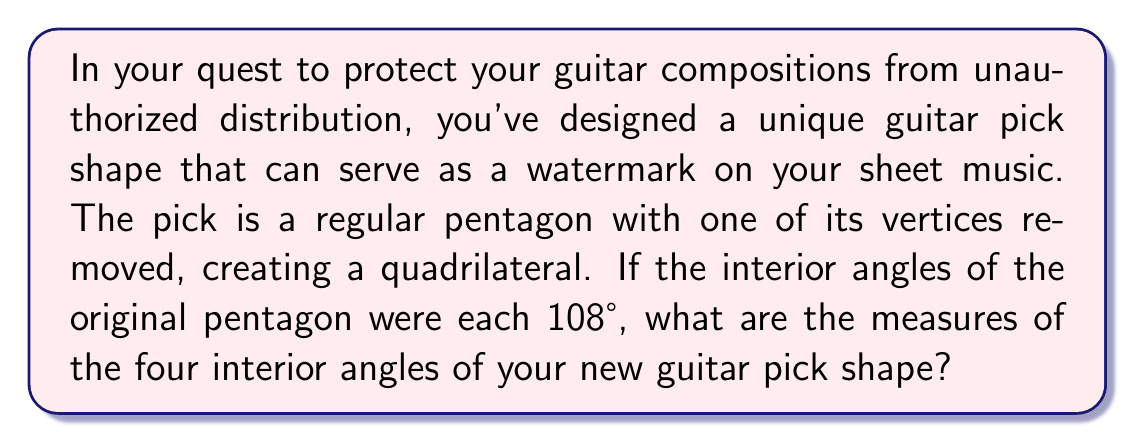Teach me how to tackle this problem. Let's approach this step-by-step:

1) First, recall that the sum of interior angles of a pentagon is given by the formula:
   $$(n-2) \times 180°$$
   where $n$ is the number of sides. For a pentagon, $n=5$:
   $$(5-2) \times 180° = 540°$$

2) In a regular pentagon, all angles are equal. Since there are 5 angles, each angle measures:
   $$\frac{540°}{5} = 108°$$

3) When we remove one vertex, we're left with a quadrilateral. The sum of interior angles of a quadrilateral is always 360°.

4) The quadrilateral we're left with has three angles from the original pentagon and one new angle formed by removing the vertex.

5) Let's call the new angle $x$. We can set up an equation:
   $$108° + 108° + 108° + x = 360°$$

6) Simplifying:
   $$324° + x = 360°$$

7) Solving for $x$:
   $$x = 360° - 324° = 36°$$

Therefore, the four interior angles of the new guitar pick shape are 108°, 108°, 108°, and 36°.
Answer: 108°, 108°, 108°, 36° 